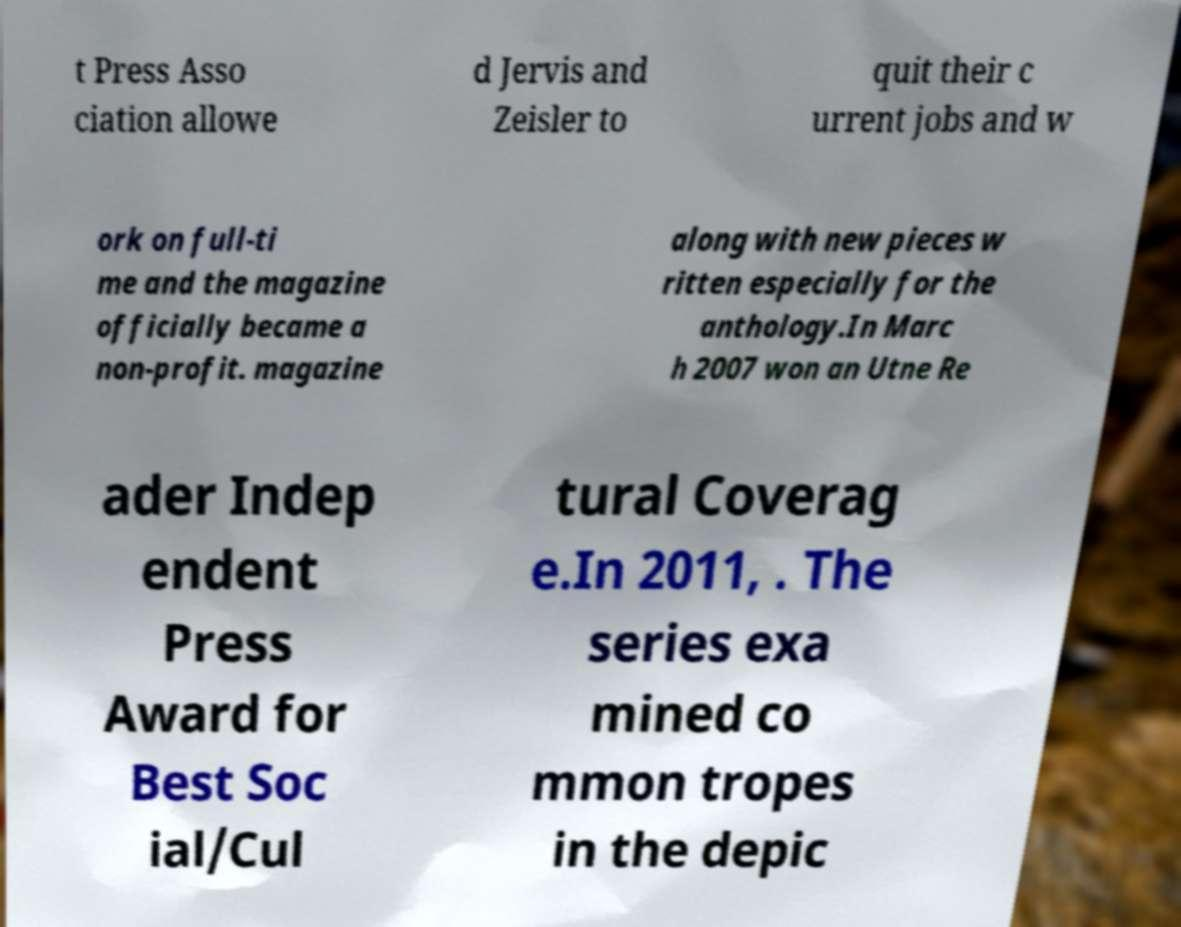Please read and relay the text visible in this image. What does it say? t Press Asso ciation allowe d Jervis and Zeisler to quit their c urrent jobs and w ork on full-ti me and the magazine officially became a non-profit. magazine along with new pieces w ritten especially for the anthology.In Marc h 2007 won an Utne Re ader Indep endent Press Award for Best Soc ial/Cul tural Coverag e.In 2011, . The series exa mined co mmon tropes in the depic 